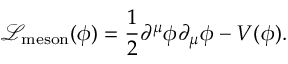<formula> <loc_0><loc_0><loc_500><loc_500>{ \mathcal { L } } _ { m e s o n } ( \phi ) = { \frac { 1 } { 2 } } \partial ^ { \mu } \phi \partial _ { \mu } \phi - V ( \phi ) .</formula> 